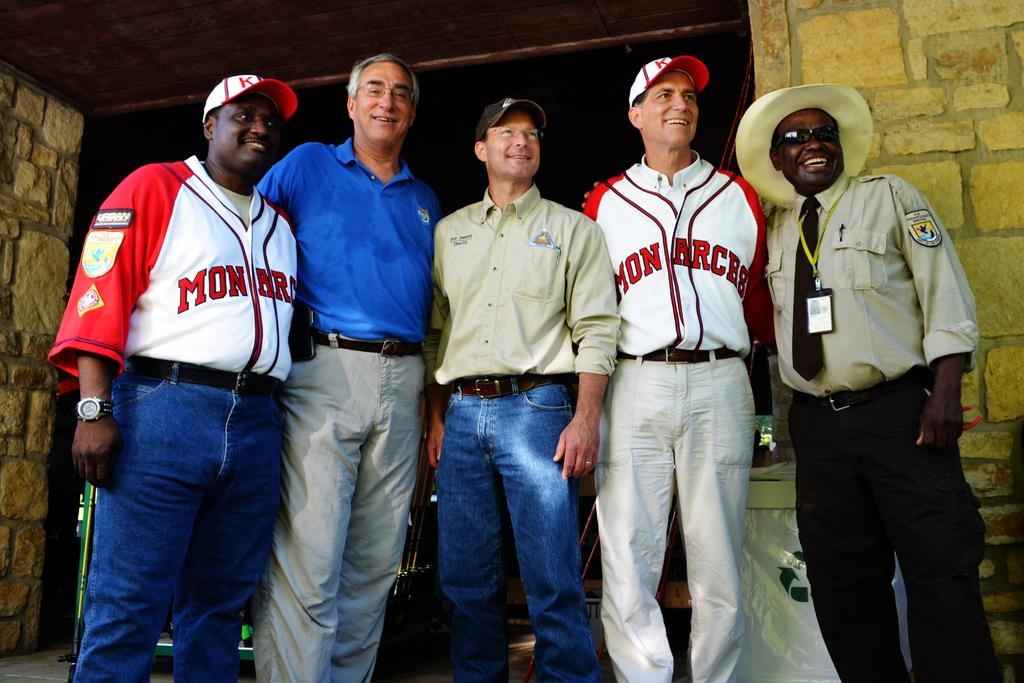<image>
Create a compact narrative representing the image presented. Two men wearing shirts that say Mon Arces on the front pose for a photo with three other men. 